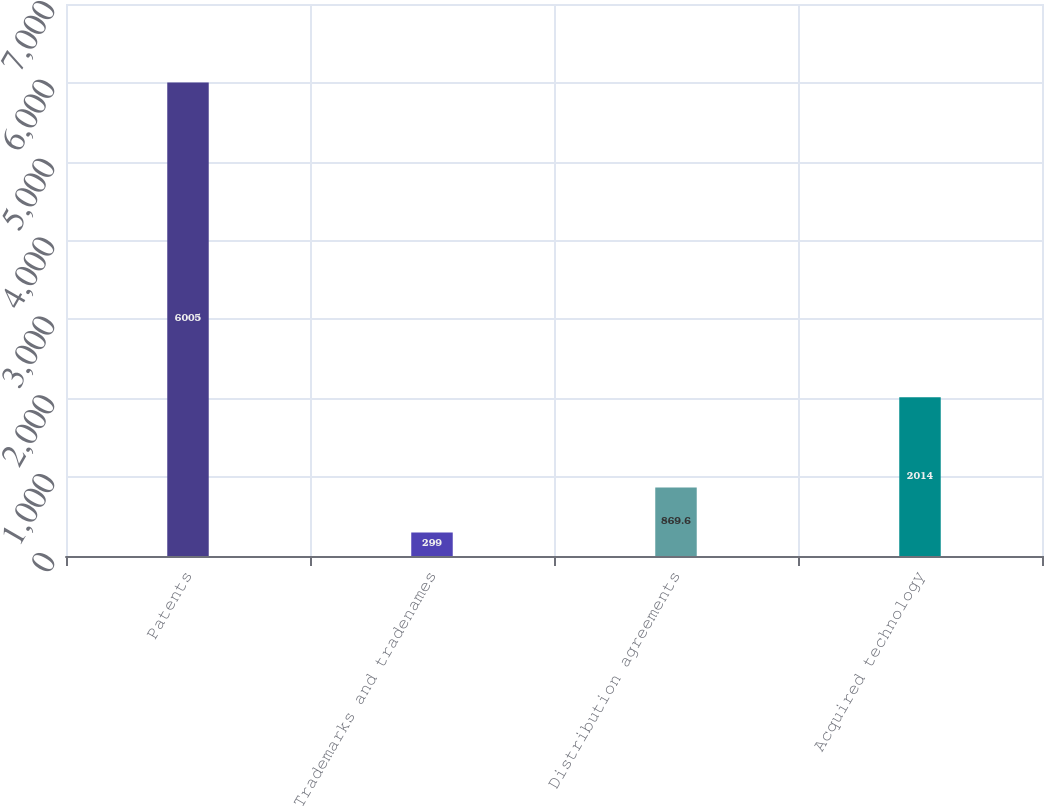Convert chart. <chart><loc_0><loc_0><loc_500><loc_500><bar_chart><fcel>Patents<fcel>Trademarks and tradenames<fcel>Distribution agreements<fcel>Acquired technology<nl><fcel>6005<fcel>299<fcel>869.6<fcel>2014<nl></chart> 